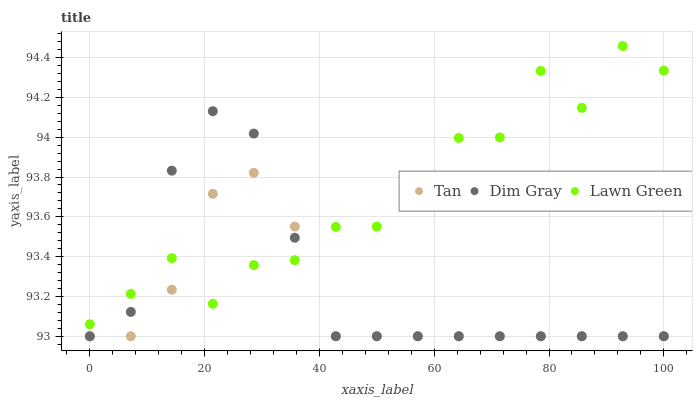Does Tan have the minimum area under the curve?
Answer yes or no. Yes. Does Lawn Green have the maximum area under the curve?
Answer yes or no. Yes. Does Dim Gray have the minimum area under the curve?
Answer yes or no. No. Does Dim Gray have the maximum area under the curve?
Answer yes or no. No. Is Tan the smoothest?
Answer yes or no. Yes. Is Lawn Green the roughest?
Answer yes or no. Yes. Is Dim Gray the smoothest?
Answer yes or no. No. Is Dim Gray the roughest?
Answer yes or no. No. Does Tan have the lowest value?
Answer yes or no. Yes. Does Lawn Green have the highest value?
Answer yes or no. Yes. Does Dim Gray have the highest value?
Answer yes or no. No. Does Tan intersect Dim Gray?
Answer yes or no. Yes. Is Tan less than Dim Gray?
Answer yes or no. No. Is Tan greater than Dim Gray?
Answer yes or no. No. 